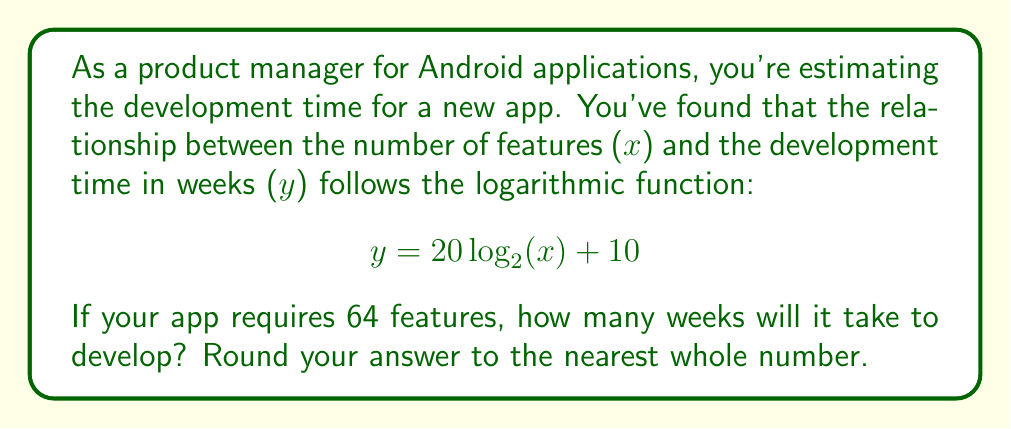Solve this math problem. To solve this problem, we need to follow these steps:

1. Identify the given information:
   - The logarithmic function: $y = 20 \log_2(x) + 10$
   - Number of features: $x = 64$

2. Substitute $x = 64$ into the equation:
   $$ y = 20 \log_2(64) + 10 $$

3. Simplify the logarithm:
   $\log_2(64) = 6$ because $2^6 = 64$

4. Calculate the result:
   $$ \begin{align}
   y &= 20 \cdot 6 + 10 \\
   y &= 120 + 10 \\
   y &= 130
   \end{align} $$

5. Round to the nearest whole number:
   130 is already a whole number, so no rounding is necessary.

Therefore, it will take 130 weeks to develop the app with 64 features.
Answer: 130 weeks 